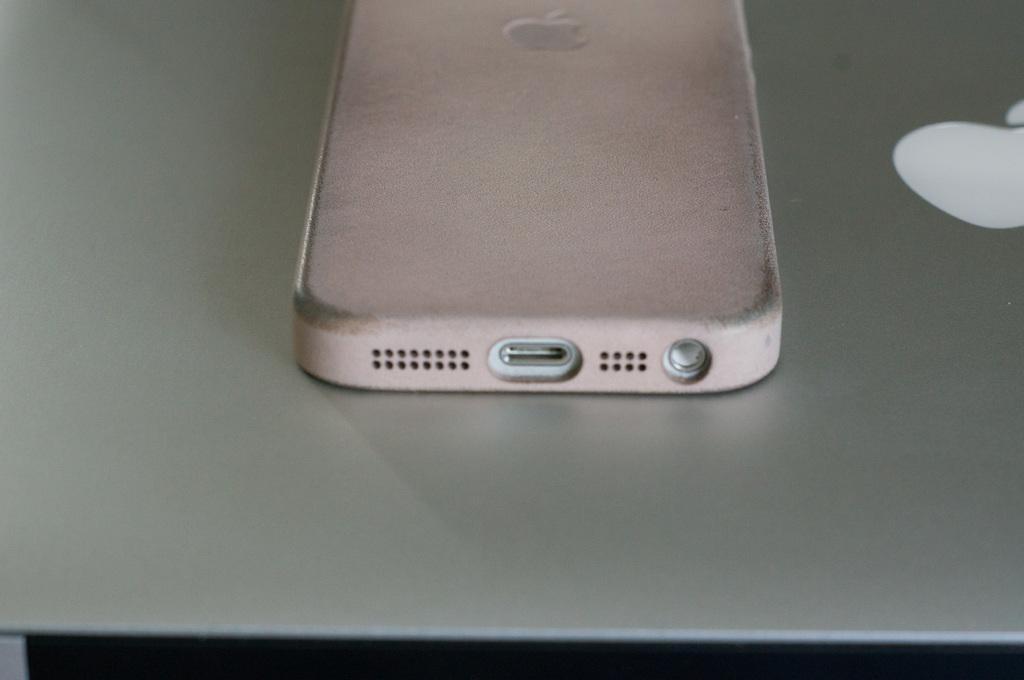Please provide a concise description of this image. In this image there is an apple mobile on the apple mac book. 